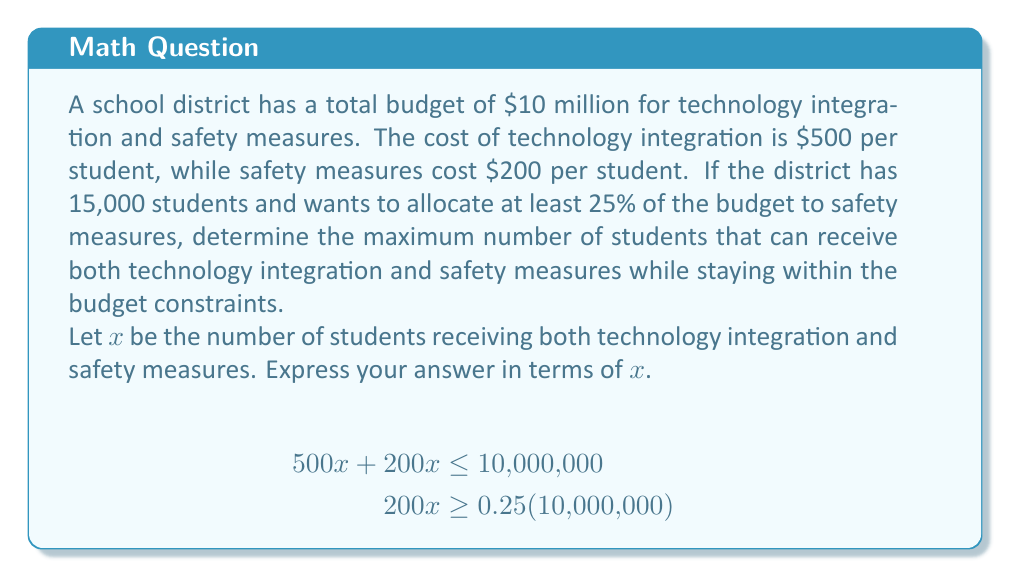Could you help me with this problem? Let's approach this step-by-step:

1) First, we need to set up our inequalities based on the given information:

   For the total budget: $500x + 200x \leq 10,000,000$
   For the safety measures (at least 25%): $200x \geq 0.25(10,000,000)$

2) Simplify the first inequality:
   $700x \leq 10,000,000$

3) Simplify the second inequality:
   $200x \geq 2,500,000$

4) From the second inequality, we can find the minimum number of students:
   $x \geq 12,500$

5) From the first inequality, we can find the maximum number of students:
   $x \leq 14,285.71$

6) Since we can't have a fractional number of students, we round down to 14,285.

7) Therefore, $x$ must be an integer that satisfies:
   $12,500 \leq x \leq 14,285$

8) The maximum value of $x$ that satisfies both conditions is 14,285.
Answer: 14,285 students 